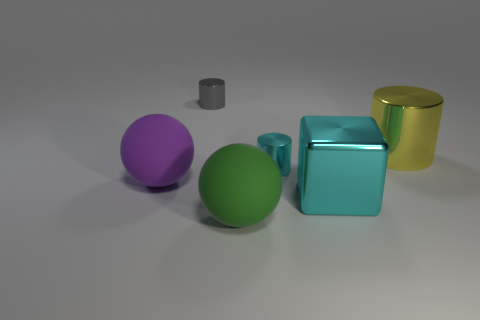The large cube has what color?
Offer a very short reply. Cyan. Is the purple thing the same size as the cyan cylinder?
Ensure brevity in your answer.  No. Is there any other thing that is the same shape as the big cyan object?
Your response must be concise. No. Is the cyan block made of the same material as the large object that is behind the purple thing?
Offer a very short reply. Yes. Do the tiny object behind the yellow cylinder and the metal block have the same color?
Make the answer very short. No. How many metallic cylinders are both behind the cyan cylinder and to the left of the big cyan shiny cube?
Your answer should be compact. 1. What number of other things are made of the same material as the green sphere?
Ensure brevity in your answer.  1. Does the ball in front of the shiny block have the same material as the big yellow cylinder?
Provide a short and direct response. No. What is the size of the rubber thing that is on the right side of the metallic object to the left of the thing in front of the large cyan metal cube?
Your answer should be compact. Large. How many other things are the same color as the shiny cube?
Offer a very short reply. 1. 